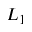Convert formula to latex. <formula><loc_0><loc_0><loc_500><loc_500>L _ { 1 }</formula> 